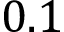<formula> <loc_0><loc_0><loc_500><loc_500>0 . 1</formula> 